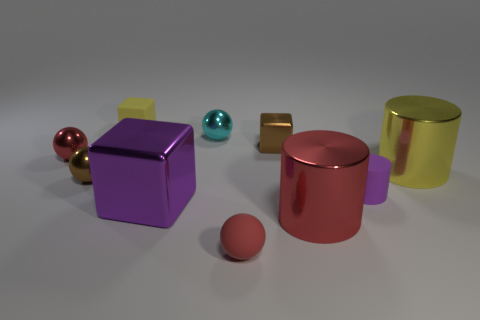How many objects are in the image, and can you categorize them by shape? There are six objects in the image. They can be categorized by shape as follows: two cubes, one sphere, two cylinders, and one smaller sphere. Are the materials of these objects all the same, and what can you tell me about their textures? The materials are not all the same. The two cubes, one sphere, and one cylinder appear to have a glossy, reflective texture, while the remaining smaller cylinder and sphere have a matt finish, giving them a different visual quality. 